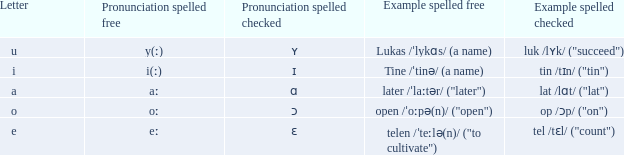What is Letter, when Example Spelled Checked is "tin /tɪn/ ("tin")"? I. 